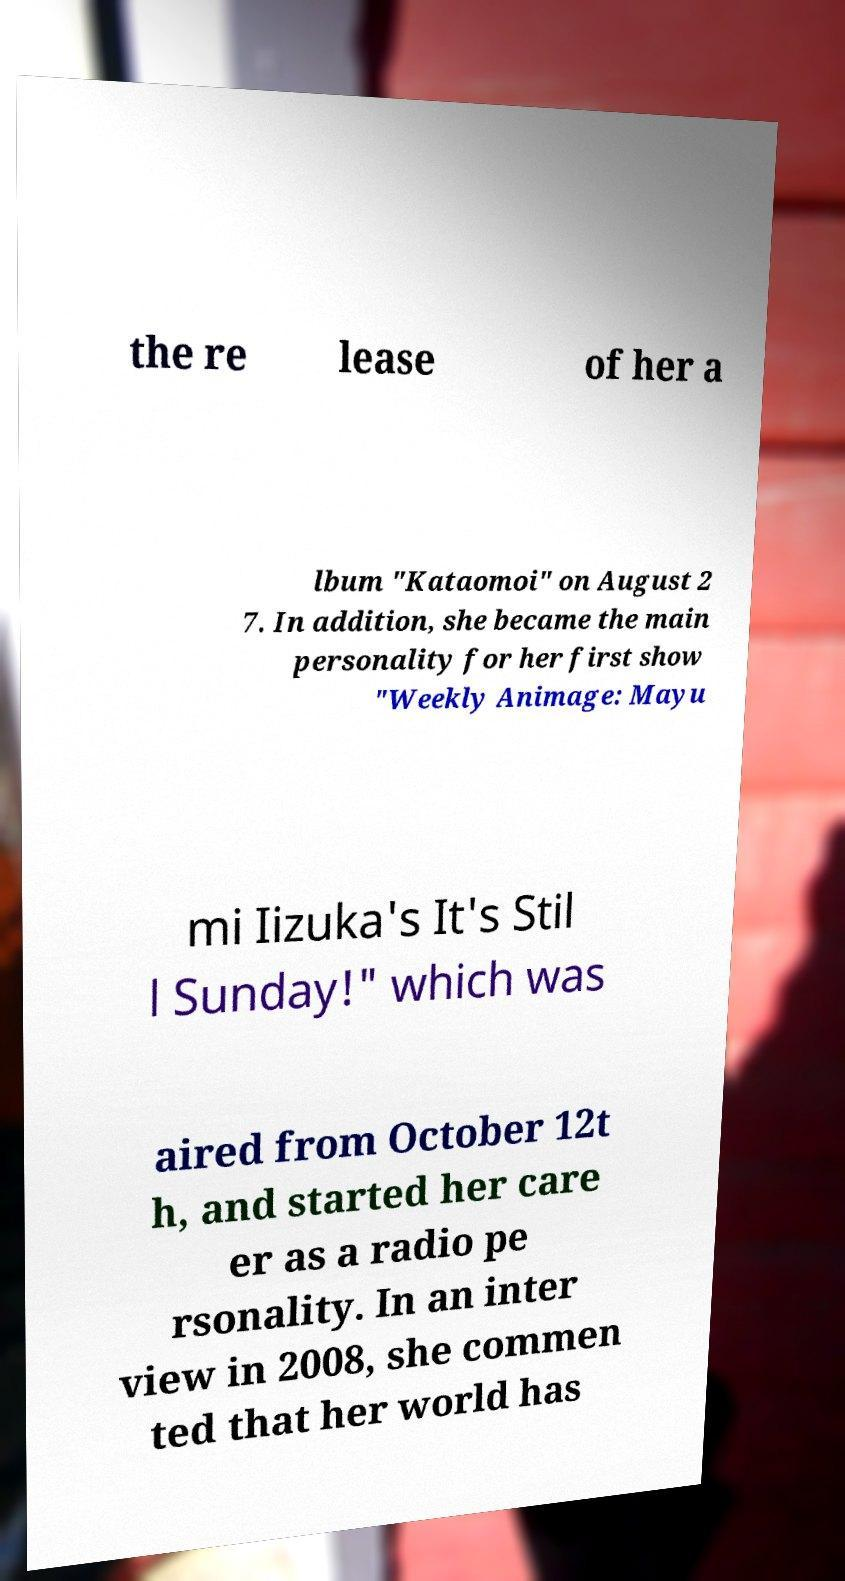Please identify and transcribe the text found in this image. the re lease of her a lbum "Kataomoi" on August 2 7. In addition, she became the main personality for her first show "Weekly Animage: Mayu mi Iizuka's It's Stil l Sunday!" which was aired from October 12t h, and started her care er as a radio pe rsonality. In an inter view in 2008, she commen ted that her world has 